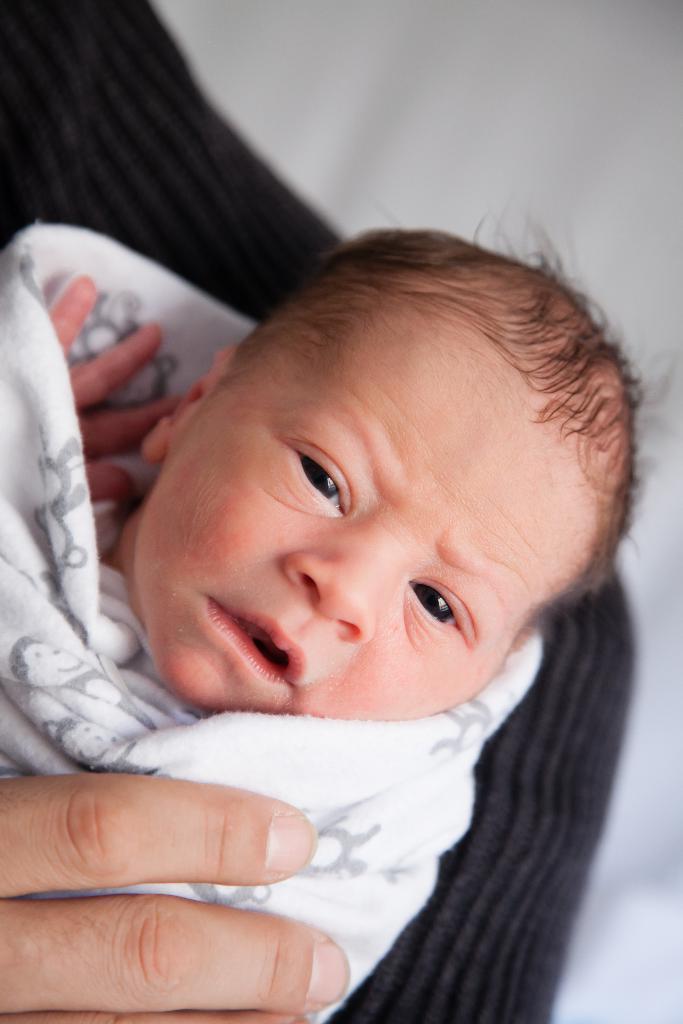Can you describe this image briefly? In this image we can see a baby in person's hand. 